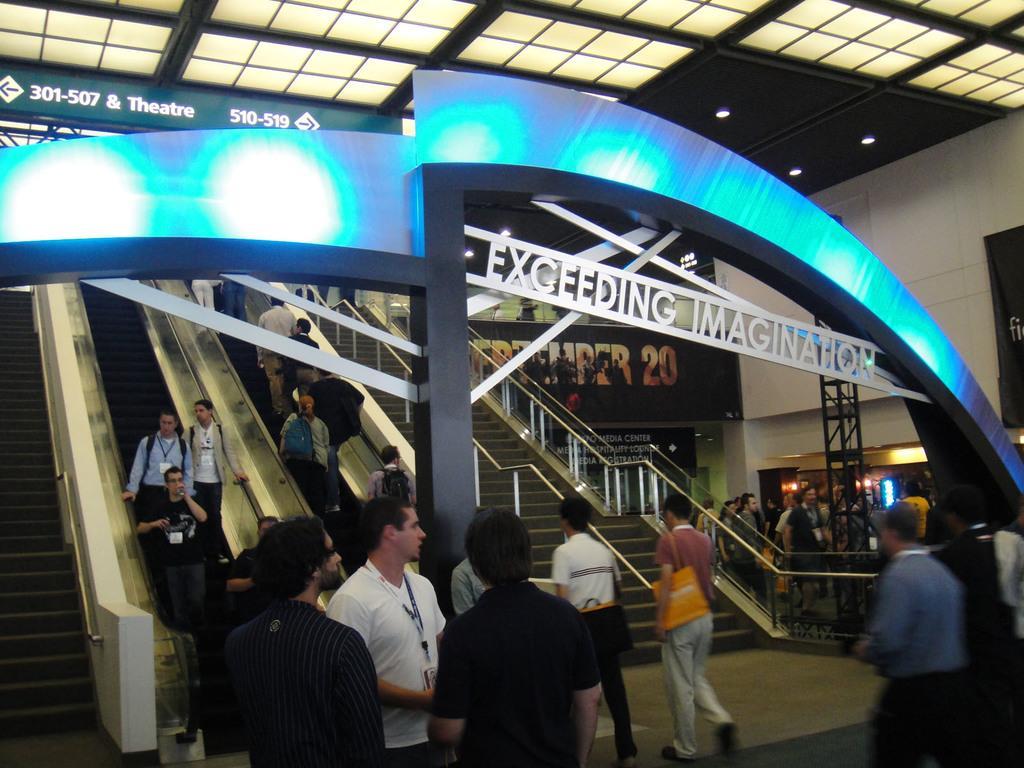In one or two sentences, can you explain what this image depicts? In this image, we can see pillars, arch, some text, banners. At the bottom of the image, we can see a group of people. Few are standing and walking. Here we can see stairs, rods, escalators. On the escalators, few people are standing. Background we can see wall, banners and lights. Top of the image, there is a glass objects and light. 